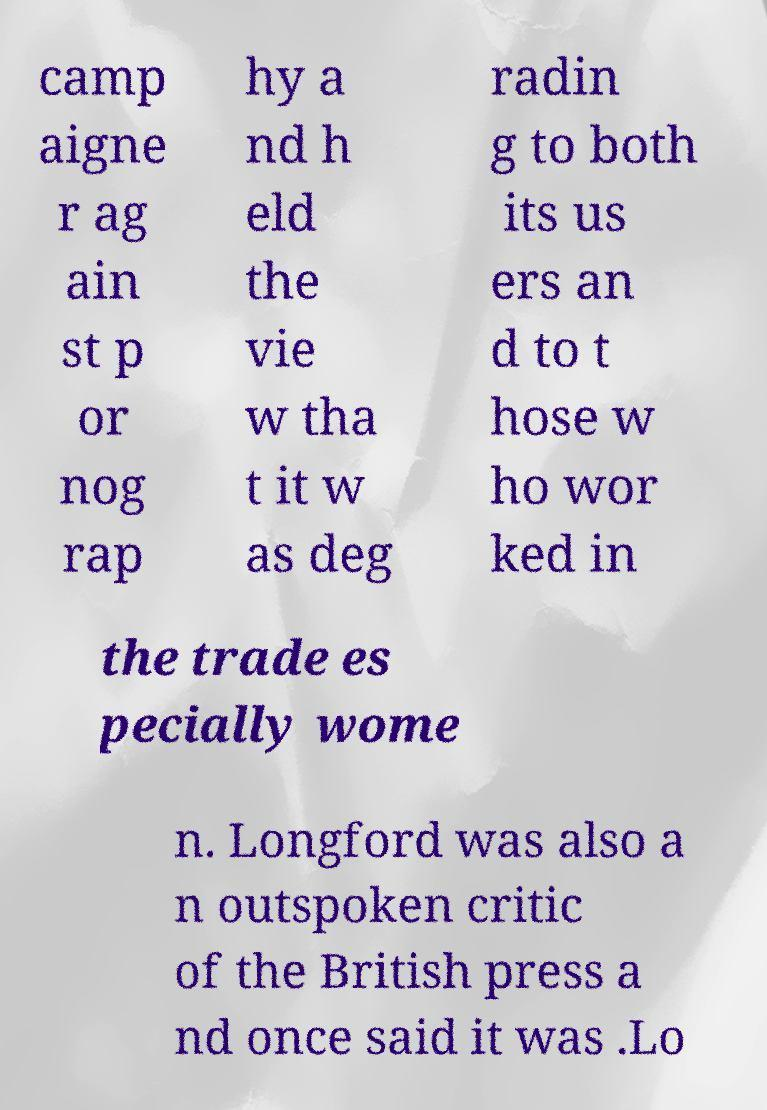There's text embedded in this image that I need extracted. Can you transcribe it verbatim? camp aigne r ag ain st p or nog rap hy a nd h eld the vie w tha t it w as deg radin g to both its us ers an d to t hose w ho wor ked in the trade es pecially wome n. Longford was also a n outspoken critic of the British press a nd once said it was .Lo 